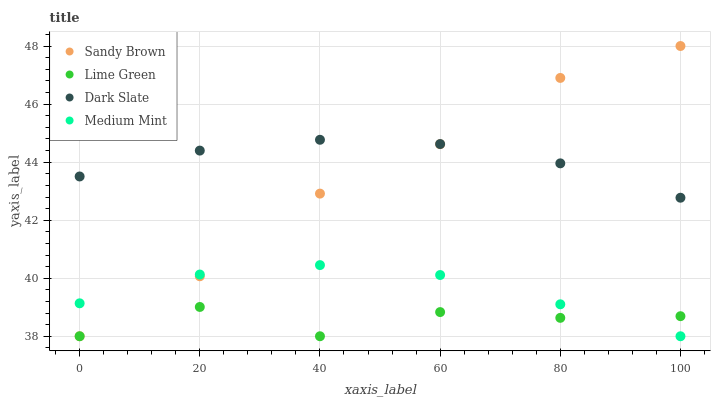Does Lime Green have the minimum area under the curve?
Answer yes or no. Yes. Does Dark Slate have the maximum area under the curve?
Answer yes or no. Yes. Does Sandy Brown have the minimum area under the curve?
Answer yes or no. No. Does Sandy Brown have the maximum area under the curve?
Answer yes or no. No. Is Dark Slate the smoothest?
Answer yes or no. Yes. Is Lime Green the roughest?
Answer yes or no. Yes. Is Sandy Brown the smoothest?
Answer yes or no. No. Is Sandy Brown the roughest?
Answer yes or no. No. Does Medium Mint have the lowest value?
Answer yes or no. Yes. Does Dark Slate have the lowest value?
Answer yes or no. No. Does Sandy Brown have the highest value?
Answer yes or no. Yes. Does Lime Green have the highest value?
Answer yes or no. No. Is Lime Green less than Dark Slate?
Answer yes or no. Yes. Is Dark Slate greater than Lime Green?
Answer yes or no. Yes. Does Medium Mint intersect Lime Green?
Answer yes or no. Yes. Is Medium Mint less than Lime Green?
Answer yes or no. No. Is Medium Mint greater than Lime Green?
Answer yes or no. No. Does Lime Green intersect Dark Slate?
Answer yes or no. No. 